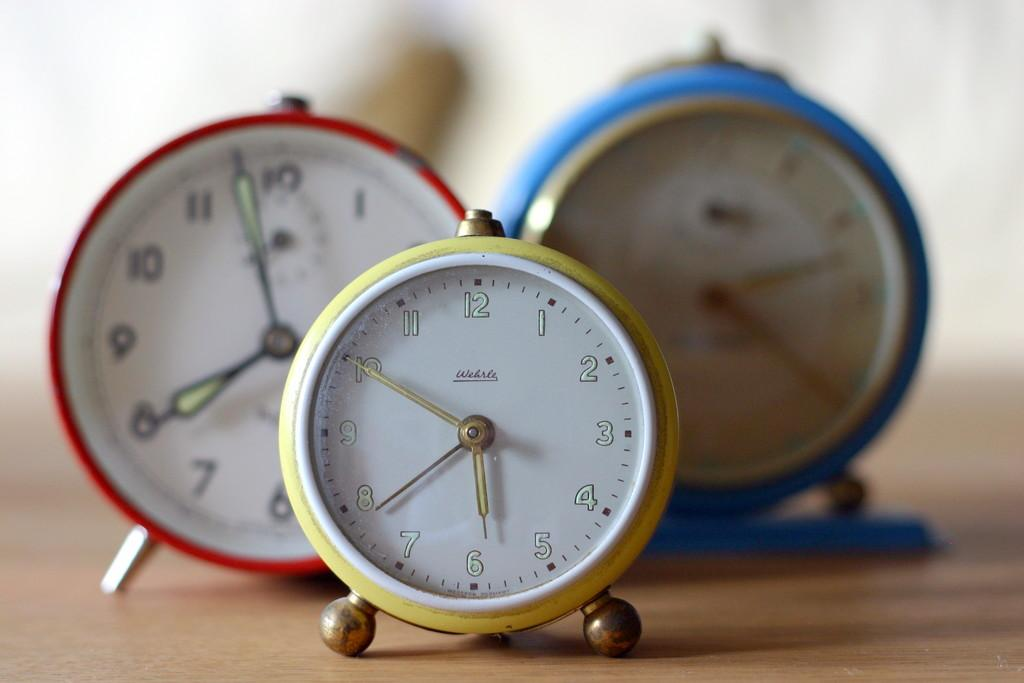<image>
Give a short and clear explanation of the subsequent image. Three different colored alarms clocks all show different times, the one in front displaying 5:50. 